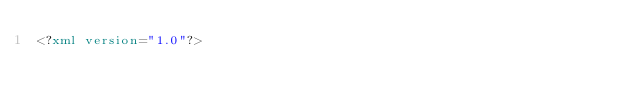<code> <loc_0><loc_0><loc_500><loc_500><_XML_><?xml version="1.0"?></code> 